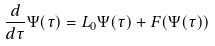Convert formula to latex. <formula><loc_0><loc_0><loc_500><loc_500>\frac { d } { d \tau } \Psi ( \tau ) = L _ { 0 } \Psi ( \tau ) + F ( \Psi ( \tau ) )</formula> 